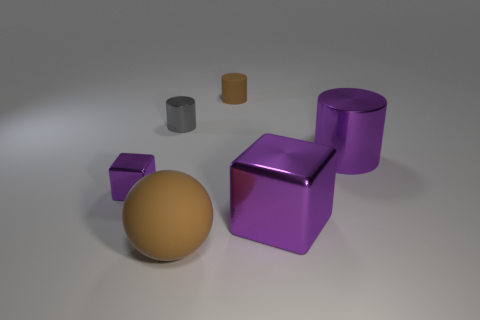Is there anything else that is the same color as the small block?
Provide a short and direct response. Yes. Are there more objects than small shiny objects?
Your response must be concise. Yes. Is the small brown object made of the same material as the big sphere?
Provide a short and direct response. Yes. How many small purple things are the same material as the big cylinder?
Keep it short and to the point. 1. Is the size of the brown rubber sphere the same as the purple shiny block that is in front of the tiny purple metal object?
Offer a terse response. Yes. What color is the tiny object that is both in front of the brown cylinder and behind the tiny purple object?
Provide a short and direct response. Gray. Is there a cylinder that is in front of the brown matte object that is right of the big rubber sphere?
Offer a very short reply. Yes. Are there the same number of small purple cubes that are on the right side of the big brown object and big shiny things?
Give a very brief answer. No. There is a shiny block in front of the block to the left of the brown rubber cylinder; what number of matte cylinders are on the right side of it?
Keep it short and to the point. 0. Is there another object of the same size as the gray metal thing?
Offer a terse response. Yes. 